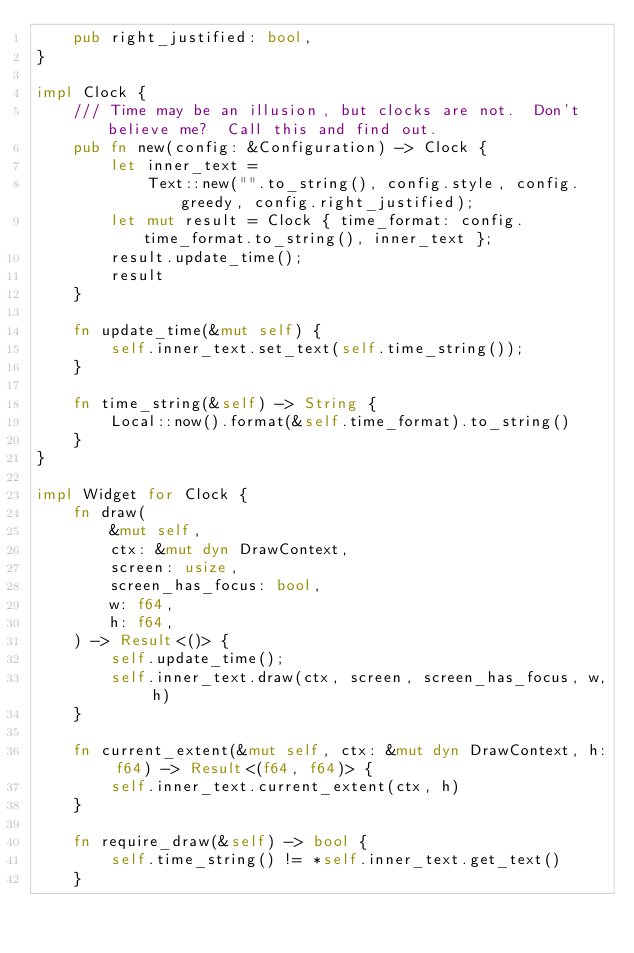<code> <loc_0><loc_0><loc_500><loc_500><_Rust_>    pub right_justified: bool,
}

impl Clock {
    /// Time may be an illusion, but clocks are not.  Don't believe me?  Call this and find out.
    pub fn new(config: &Configuration) -> Clock {
        let inner_text =
            Text::new("".to_string(), config.style, config.greedy, config.right_justified);
        let mut result = Clock { time_format: config.time_format.to_string(), inner_text };
        result.update_time();
        result
    }

    fn update_time(&mut self) {
        self.inner_text.set_text(self.time_string());
    }

    fn time_string(&self) -> String {
        Local::now().format(&self.time_format).to_string()
    }
}

impl Widget for Clock {
    fn draw(
        &mut self,
        ctx: &mut dyn DrawContext,
        screen: usize,
        screen_has_focus: bool,
        w: f64,
        h: f64,
    ) -> Result<()> {
        self.update_time();
        self.inner_text.draw(ctx, screen, screen_has_focus, w, h)
    }

    fn current_extent(&mut self, ctx: &mut dyn DrawContext, h: f64) -> Result<(f64, f64)> {
        self.inner_text.current_extent(ctx, h)
    }

    fn require_draw(&self) -> bool {
        self.time_string() != *self.inner_text.get_text()
    }
</code> 